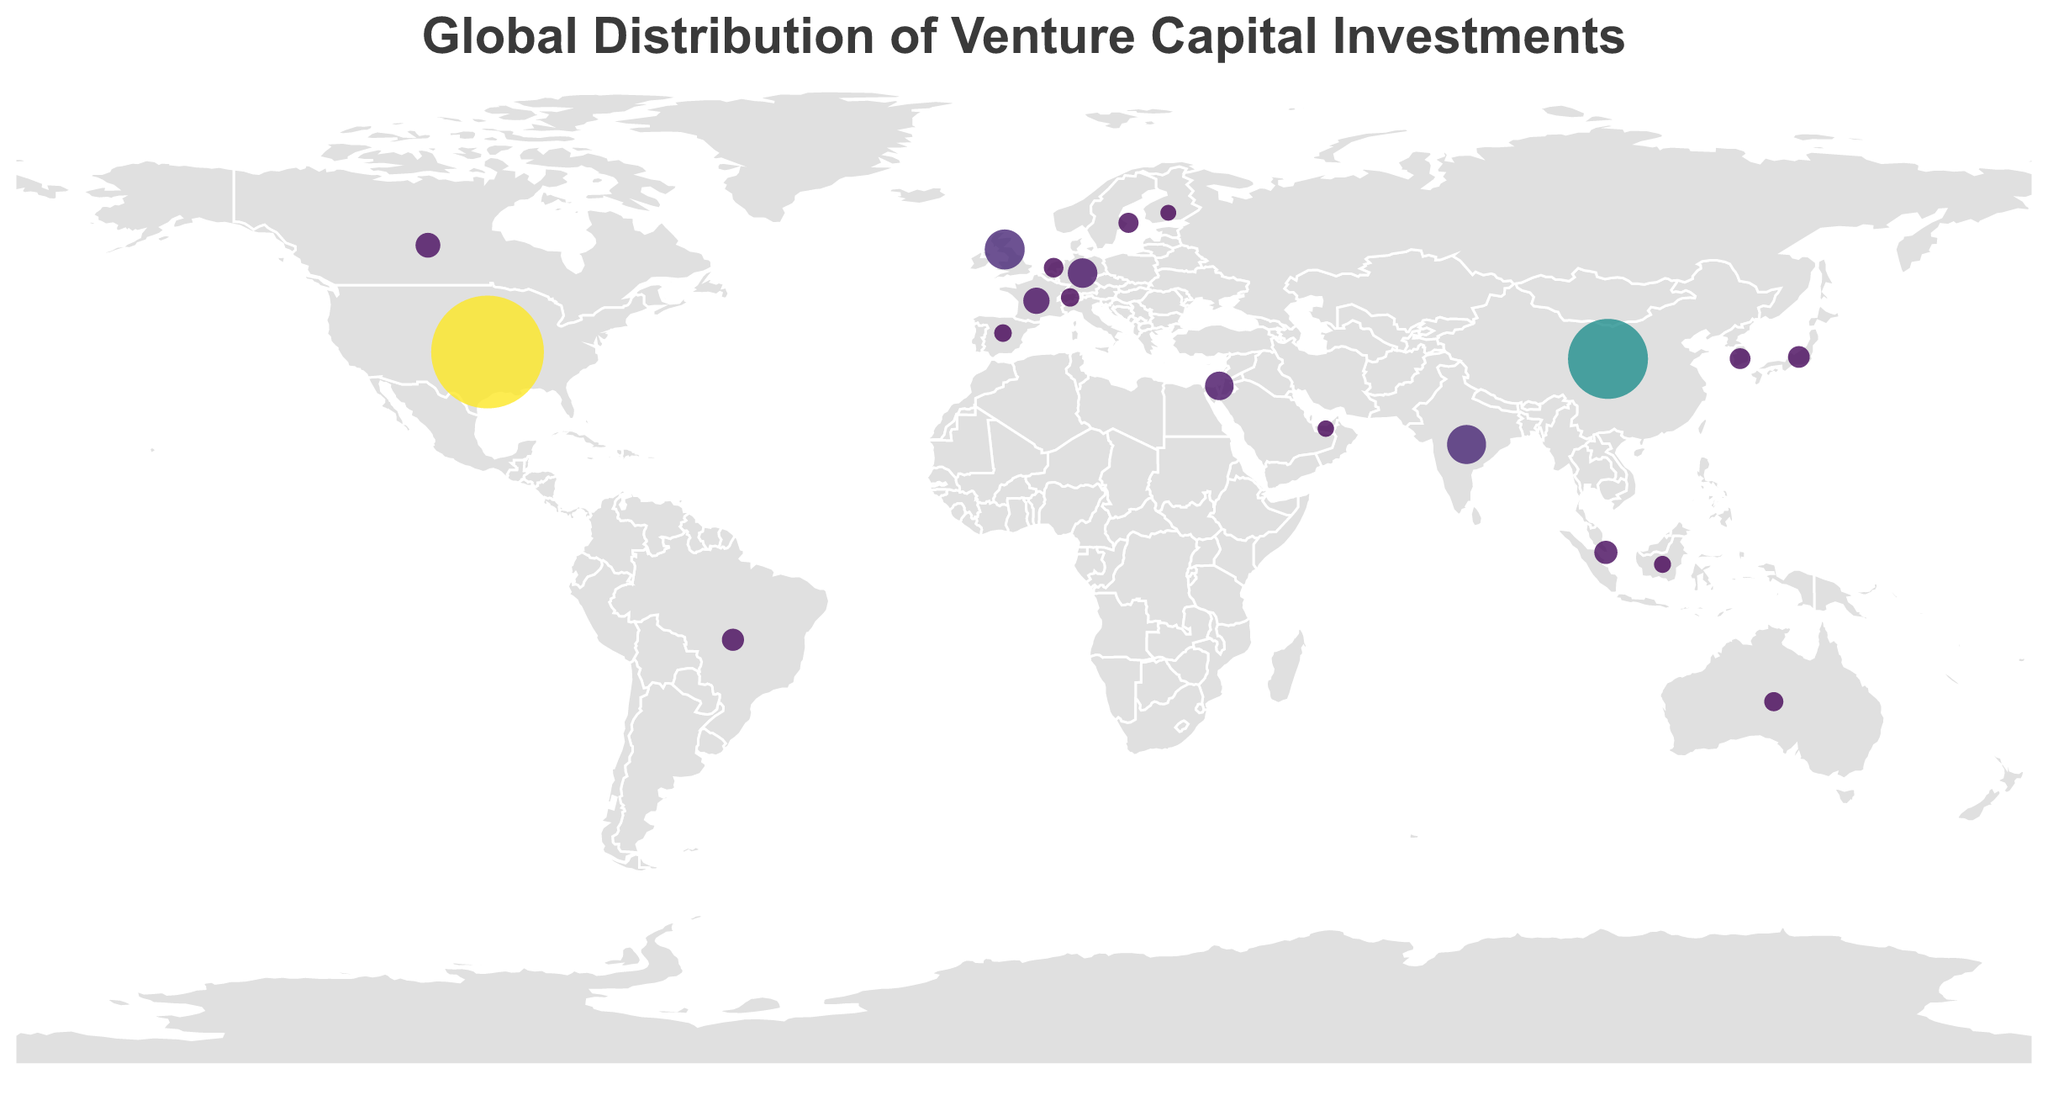Which country has the highest venture capital investment? The country with the largest circle on the map and the tooltip showing the highest investment value indicates the highest venture capital investment. In this case, the United States.
Answer: United States Which country has the lowest venture capital investment among those listed? The country with the smallest circle on the map and the tooltip showing the lowest investment value indicates the lowest venture capital investment. In this case, Finland.
Answer: Finland What is the total venture capital investment of the top three countries? Summing the venture capital investments of the United States (130.9), China (65.2), and the United Kingdom (15.3) gives the total. 130.9 + 65.2 + 15.3 = 211.4
Answer: 211.4 How does the venture capital investment in France compare to that in Canada? By looking at the sizes and colors of the circles for France and Canada, and confirming with the tooltip values, we can see that France (5.9) has a higher investment than Canada (5.1).
Answer: France has a higher investment What is the combined venture capital investment of Germany and Israel? Summing the venture capital investments of Germany (7.8) and Israel (7.2) gives the combined total. 7.8 + 7.2 = 15.0
Answer: 15.0 Which countries have venture capital investments between $3 billion and $5 billion? Identify the countries with circles sized between these values on the map and confirm using the tooltips. These countries are Singapore, Brazil, Japan, and South Korea.
Answer: Singapore, Brazil, Japan, South Korea How does the venture capital investment in the United Kingdom compare to that in India? By looking at the sizes and colors of the circles for the United Kingdom and India, and confirming with the tooltip values, we can see that the United Kingdom (15.3) has a higher investment than India (14.5).
Answer: The United Kingdom has a higher investment Which European country has the highest venture capital investment? Identify the European country with the largest circle on the map and verify with the tooltip values. In this case, the United Kingdom.
Answer: United Kingdom What is the average venture capital investment of the listed countries? Sum the venture capital investments of all the listed countries and divide by the number of countries. (130.9 + 65.2 + 15.3 + 14.5 + 7.8 + 7.2 + 5.9 + 5.1 + 4.3 + 3.8 + 3.6 + 3.2 + 2.9 + 2.7 + 2.5 + 2.2 + 1.9 + 1.7 + 1.5 + 1.3) / 20 = 14.95
Answer: 14.95 What percentage of total venture capital investment does the United States represent? Calculate the percentage by dividing the venture capital investment of the United States by the total investment of all countries, then multiply by 100. (130.9 / 299) * 100 ≈ 43.8%
Answer: 43.8% 